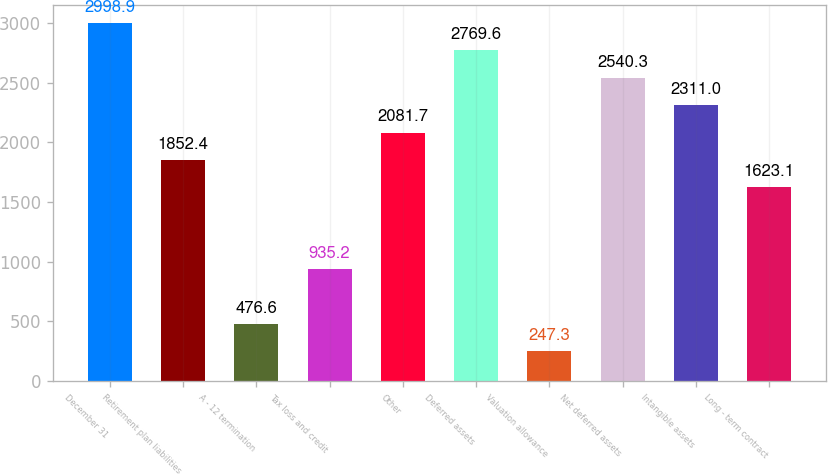<chart> <loc_0><loc_0><loc_500><loc_500><bar_chart><fcel>December 31<fcel>Retirement plan liabilities<fcel>A - 12 termination<fcel>Tax loss and credit<fcel>Other<fcel>Deferred assets<fcel>Valuation allowance<fcel>Net deferred assets<fcel>Intangible assets<fcel>Long - term contract<nl><fcel>2998.9<fcel>1852.4<fcel>476.6<fcel>935.2<fcel>2081.7<fcel>2769.6<fcel>247.3<fcel>2540.3<fcel>2311<fcel>1623.1<nl></chart> 